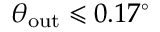<formula> <loc_0><loc_0><loc_500><loc_500>\theta _ { o u t } \leqslant 0 . 1 7 ^ { \circ }</formula> 